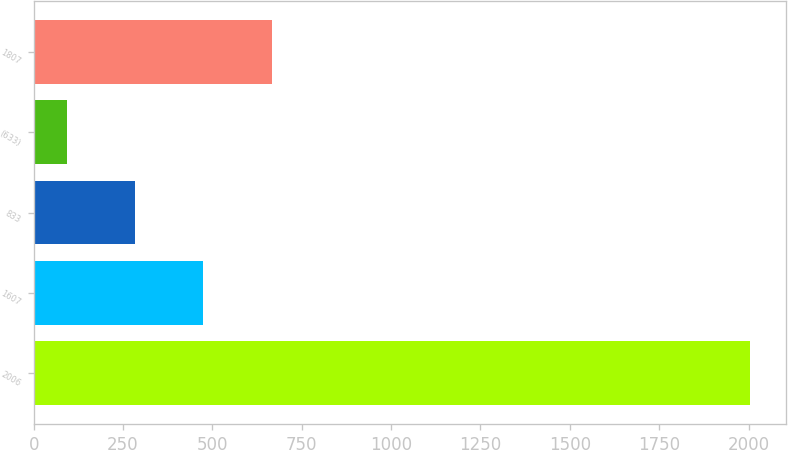Convert chart. <chart><loc_0><loc_0><loc_500><loc_500><bar_chart><fcel>2006<fcel>1607<fcel>833<fcel>(633)<fcel>1807<nl><fcel>2005<fcel>474.6<fcel>283.3<fcel>92<fcel>665.9<nl></chart> 